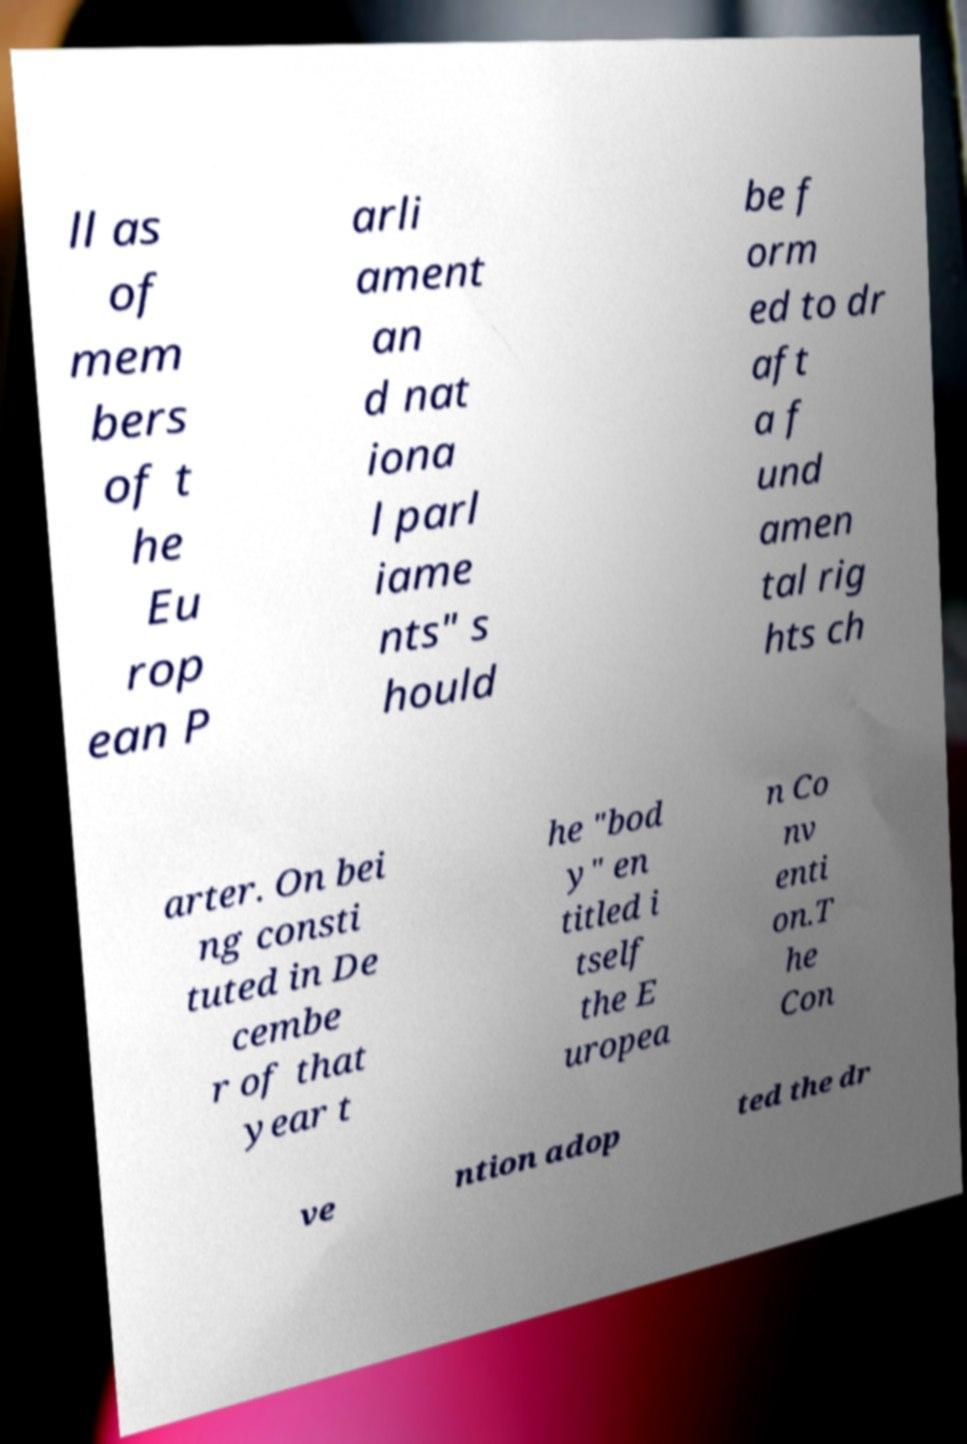Please identify and transcribe the text found in this image. ll as of mem bers of t he Eu rop ean P arli ament an d nat iona l parl iame nts" s hould be f orm ed to dr aft a f und amen tal rig hts ch arter. On bei ng consti tuted in De cembe r of that year t he "bod y" en titled i tself the E uropea n Co nv enti on.T he Con ve ntion adop ted the dr 